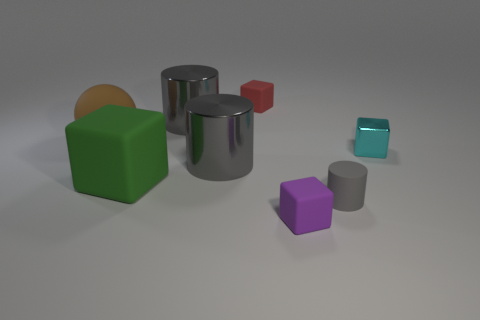Is there any other thing that is the same size as the brown rubber thing?
Provide a short and direct response. Yes. What shape is the metallic object on the right side of the red block?
Give a very brief answer. Cube. What size is the red block that is made of the same material as the green thing?
Offer a terse response. Small. How many purple shiny things are the same shape as the green rubber thing?
Provide a succinct answer. 0. There is a big cylinder in front of the big brown rubber sphere; is its color the same as the big block?
Provide a short and direct response. No. How many purple rubber cubes are behind the block in front of the matte thing on the right side of the tiny purple rubber cube?
Make the answer very short. 0. How many tiny objects are right of the red thing and on the left side of the gray matte thing?
Your answer should be very brief. 1. Is there any other thing that has the same material as the purple object?
Give a very brief answer. Yes. Are the tiny red object and the small gray object made of the same material?
Your answer should be compact. Yes. There is a large metallic object to the right of the metal cylinder behind the metallic object that is on the right side of the matte cylinder; what is its shape?
Keep it short and to the point. Cylinder. 